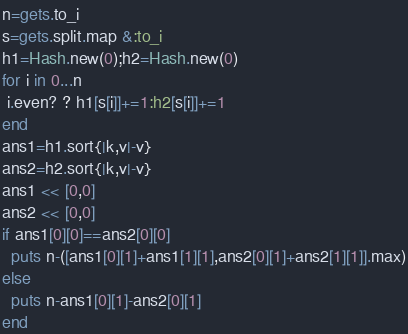Convert code to text. <code><loc_0><loc_0><loc_500><loc_500><_Ruby_>n=gets.to_i
s=gets.split.map &:to_i
h1=Hash.new(0);h2=Hash.new(0)
for i in 0...n
 i.even? ? h1[s[i]]+=1:h2[s[i]]+=1
end
ans1=h1.sort{|k,v|-v}
ans2=h2.sort{|k,v|-v}
ans1 << [0,0]
ans2 << [0,0]
if ans1[0][0]==ans2[0][0]
  puts n-([ans1[0][1]+ans1[1][1],ans2[0][1]+ans2[1][1]].max)
else
  puts n-ans1[0][1]-ans2[0][1]
end
</code> 